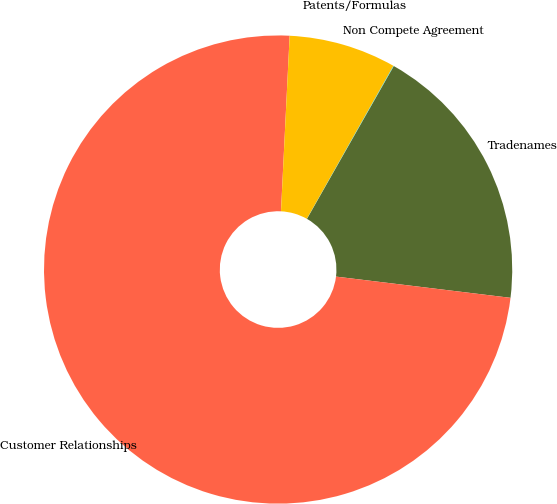Convert chart to OTSL. <chart><loc_0><loc_0><loc_500><loc_500><pie_chart><fcel>Tradenames<fcel>Customer Relationships<fcel>Patents/Formulas<fcel>Non Compete Agreement<nl><fcel>18.7%<fcel>73.85%<fcel>7.41%<fcel>0.03%<nl></chart> 